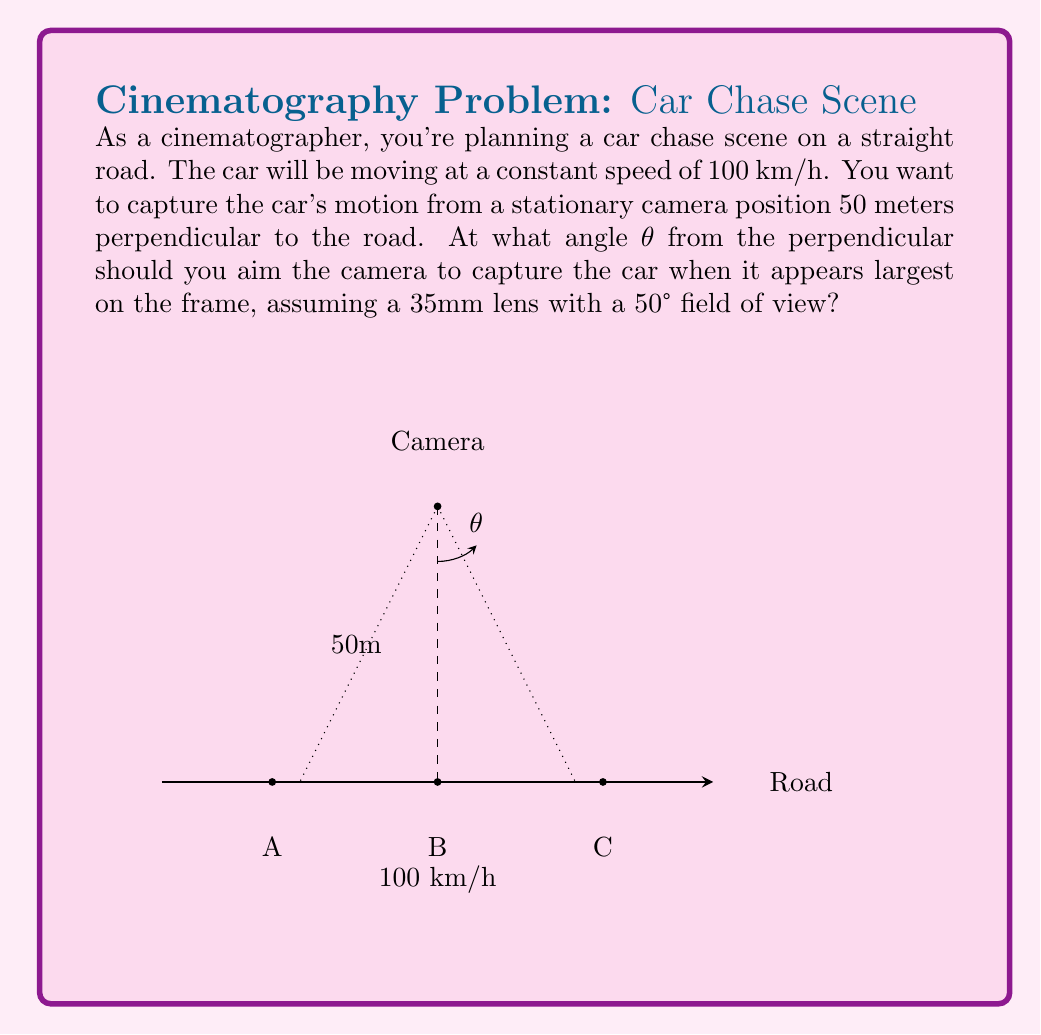What is the answer to this math problem? To solve this problem, we need to understand that the car will appear largest when it fills the most of the camera's field of view. This occurs when the car is at the closest point to the camera, which is directly perpendicular to the camera's position (point B in the diagram).

Let's approach this step-by-step:

1) The camera's field of view is 50°. We want the car to be in the center of this field when it's at point B.

2) The optimal angle θ will be half of the field of view:

   $$\theta = \frac{50°}{2} = 25°$$

3) We can verify this using trigonometry. The tangent of the angle θ is the ratio of the opposite side (distance along the road) to the adjacent side (perpendicular distance to the road):

   $$\tan(\theta) = \frac{\text{distance along road}}{50\text{ m}}$$

4) We can calculate the distance along the road that corresponds to a 25° angle:

   $$\text{distance along road} = 50\text{ m} \times \tan(25°)$$
   $$\approx 50\text{ m} \times 0.4663 \approx 23.3\text{ m}$$

5) This means that when the car is about 23.3 meters before or after point B, it will be at the edge of the camera's field of view.

6) We can check if this makes sense with the car's speed:
   - At 100 km/h, the car travels 27.8 m/s
   - It will take about 1.68 seconds to travel from one edge of the frame to the other (46.6 m / 27.8 m/s)
   - This is a reasonable duration for a dramatic shot in a car chase scene

Therefore, aiming the camera at a 25° angle from the perpendicular will capture the car when it appears largest in the frame.
Answer: 25° 